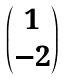<formula> <loc_0><loc_0><loc_500><loc_500>\begin{pmatrix} 1 \\ - 2 \end{pmatrix}</formula> 